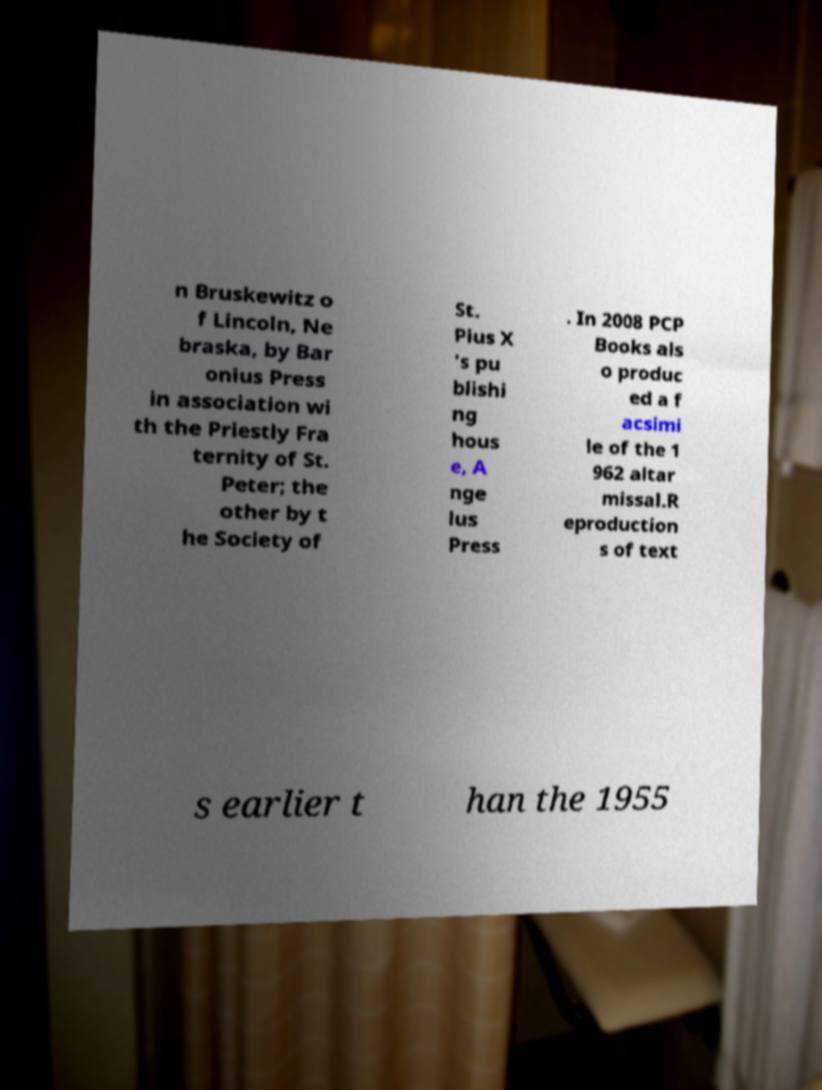There's text embedded in this image that I need extracted. Can you transcribe it verbatim? n Bruskewitz o f Lincoln, Ne braska, by Bar onius Press in association wi th the Priestly Fra ternity of St. Peter; the other by t he Society of St. Pius X 's pu blishi ng hous e, A nge lus Press . In 2008 PCP Books als o produc ed a f acsimi le of the 1 962 altar missal.R eproduction s of text s earlier t han the 1955 